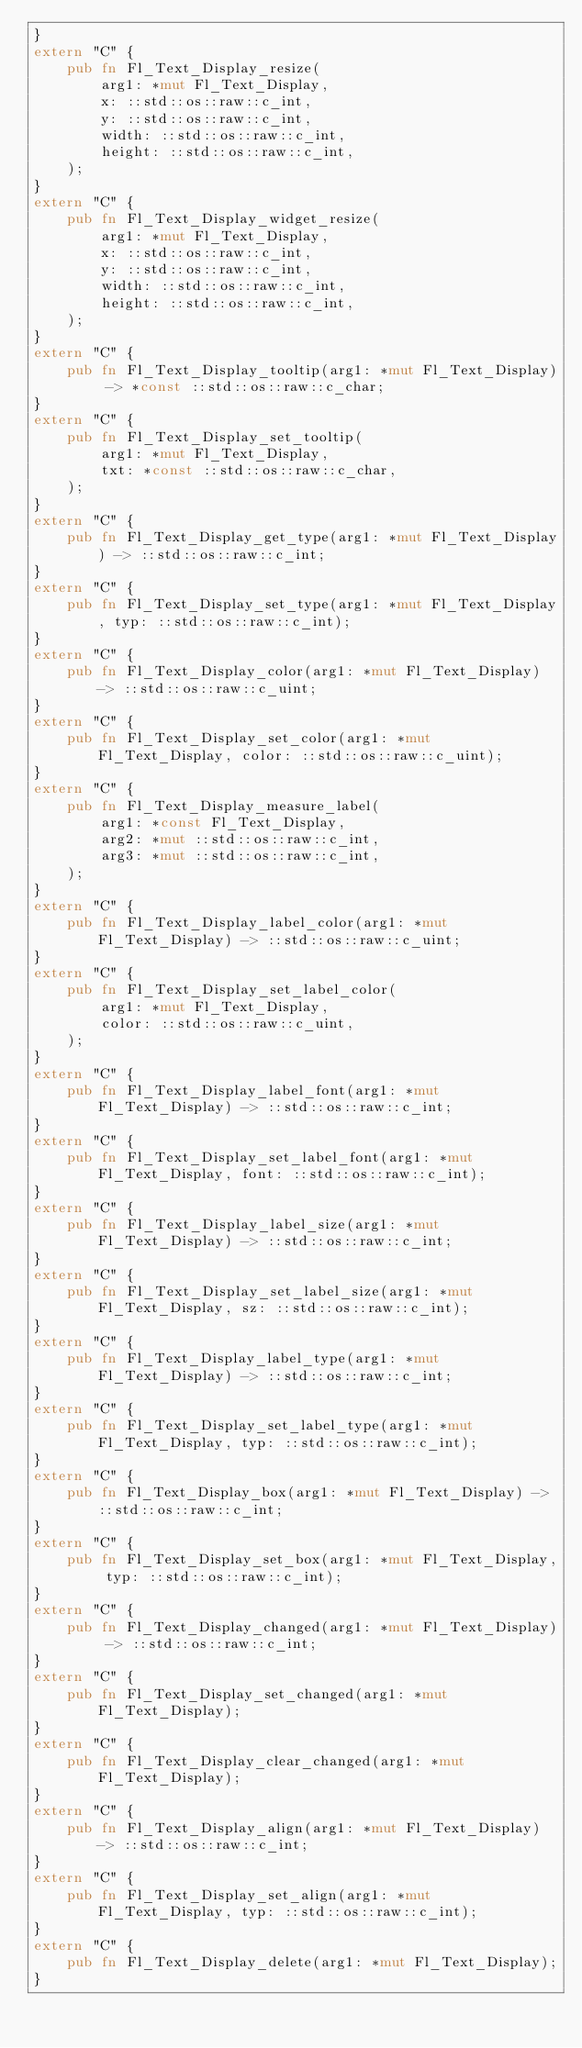Convert code to text. <code><loc_0><loc_0><loc_500><loc_500><_Rust_>}
extern "C" {
    pub fn Fl_Text_Display_resize(
        arg1: *mut Fl_Text_Display,
        x: ::std::os::raw::c_int,
        y: ::std::os::raw::c_int,
        width: ::std::os::raw::c_int,
        height: ::std::os::raw::c_int,
    );
}
extern "C" {
    pub fn Fl_Text_Display_widget_resize(
        arg1: *mut Fl_Text_Display,
        x: ::std::os::raw::c_int,
        y: ::std::os::raw::c_int,
        width: ::std::os::raw::c_int,
        height: ::std::os::raw::c_int,
    );
}
extern "C" {
    pub fn Fl_Text_Display_tooltip(arg1: *mut Fl_Text_Display) -> *const ::std::os::raw::c_char;
}
extern "C" {
    pub fn Fl_Text_Display_set_tooltip(
        arg1: *mut Fl_Text_Display,
        txt: *const ::std::os::raw::c_char,
    );
}
extern "C" {
    pub fn Fl_Text_Display_get_type(arg1: *mut Fl_Text_Display) -> ::std::os::raw::c_int;
}
extern "C" {
    pub fn Fl_Text_Display_set_type(arg1: *mut Fl_Text_Display, typ: ::std::os::raw::c_int);
}
extern "C" {
    pub fn Fl_Text_Display_color(arg1: *mut Fl_Text_Display) -> ::std::os::raw::c_uint;
}
extern "C" {
    pub fn Fl_Text_Display_set_color(arg1: *mut Fl_Text_Display, color: ::std::os::raw::c_uint);
}
extern "C" {
    pub fn Fl_Text_Display_measure_label(
        arg1: *const Fl_Text_Display,
        arg2: *mut ::std::os::raw::c_int,
        arg3: *mut ::std::os::raw::c_int,
    );
}
extern "C" {
    pub fn Fl_Text_Display_label_color(arg1: *mut Fl_Text_Display) -> ::std::os::raw::c_uint;
}
extern "C" {
    pub fn Fl_Text_Display_set_label_color(
        arg1: *mut Fl_Text_Display,
        color: ::std::os::raw::c_uint,
    );
}
extern "C" {
    pub fn Fl_Text_Display_label_font(arg1: *mut Fl_Text_Display) -> ::std::os::raw::c_int;
}
extern "C" {
    pub fn Fl_Text_Display_set_label_font(arg1: *mut Fl_Text_Display, font: ::std::os::raw::c_int);
}
extern "C" {
    pub fn Fl_Text_Display_label_size(arg1: *mut Fl_Text_Display) -> ::std::os::raw::c_int;
}
extern "C" {
    pub fn Fl_Text_Display_set_label_size(arg1: *mut Fl_Text_Display, sz: ::std::os::raw::c_int);
}
extern "C" {
    pub fn Fl_Text_Display_label_type(arg1: *mut Fl_Text_Display) -> ::std::os::raw::c_int;
}
extern "C" {
    pub fn Fl_Text_Display_set_label_type(arg1: *mut Fl_Text_Display, typ: ::std::os::raw::c_int);
}
extern "C" {
    pub fn Fl_Text_Display_box(arg1: *mut Fl_Text_Display) -> ::std::os::raw::c_int;
}
extern "C" {
    pub fn Fl_Text_Display_set_box(arg1: *mut Fl_Text_Display, typ: ::std::os::raw::c_int);
}
extern "C" {
    pub fn Fl_Text_Display_changed(arg1: *mut Fl_Text_Display) -> ::std::os::raw::c_int;
}
extern "C" {
    pub fn Fl_Text_Display_set_changed(arg1: *mut Fl_Text_Display);
}
extern "C" {
    pub fn Fl_Text_Display_clear_changed(arg1: *mut Fl_Text_Display);
}
extern "C" {
    pub fn Fl_Text_Display_align(arg1: *mut Fl_Text_Display) -> ::std::os::raw::c_int;
}
extern "C" {
    pub fn Fl_Text_Display_set_align(arg1: *mut Fl_Text_Display, typ: ::std::os::raw::c_int);
}
extern "C" {
    pub fn Fl_Text_Display_delete(arg1: *mut Fl_Text_Display);
}</code> 